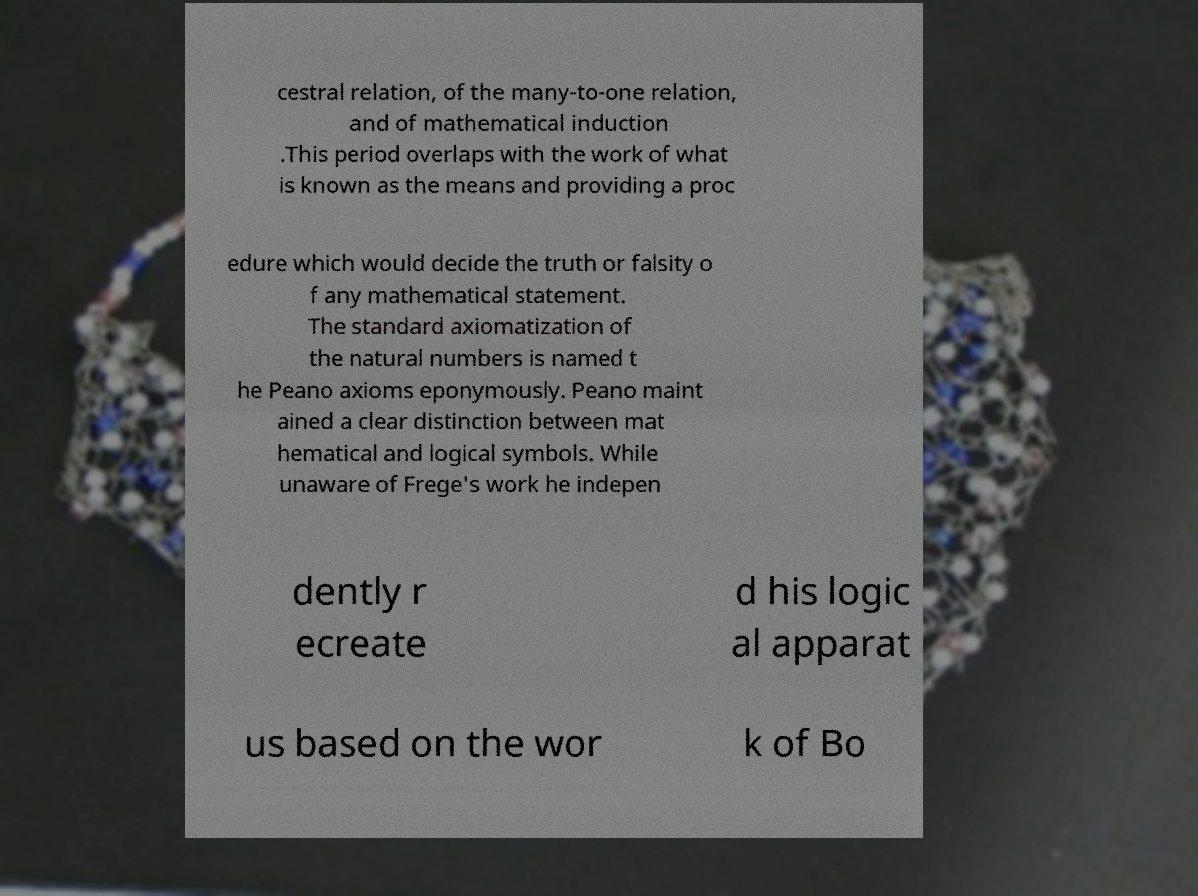Can you accurately transcribe the text from the provided image for me? cestral relation, of the many-to-one relation, and of mathematical induction .This period overlaps with the work of what is known as the means and providing a proc edure which would decide the truth or falsity o f any mathematical statement. The standard axiomatization of the natural numbers is named t he Peano axioms eponymously. Peano maint ained a clear distinction between mat hematical and logical symbols. While unaware of Frege's work he indepen dently r ecreate d his logic al apparat us based on the wor k of Bo 